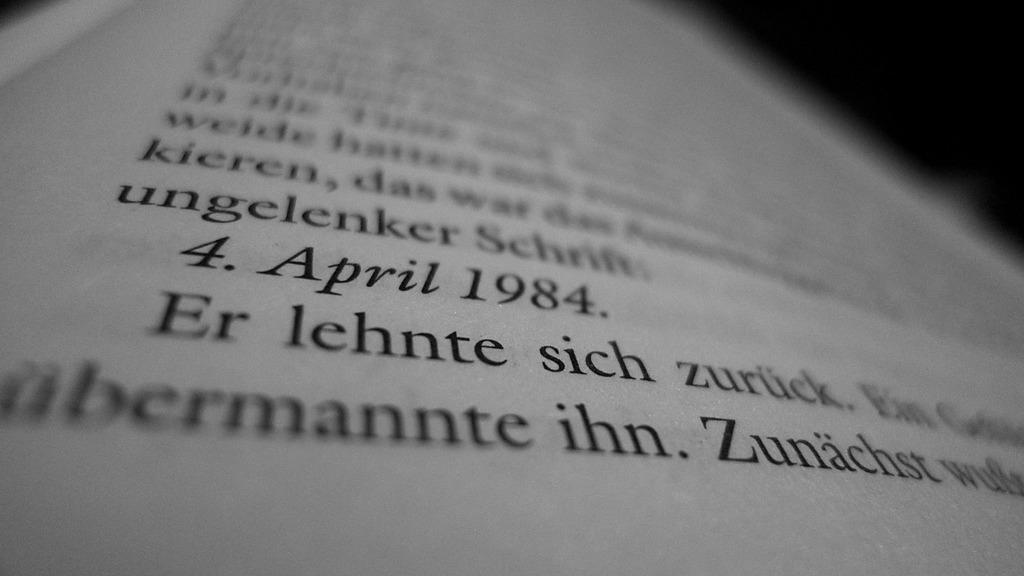What is the date given?
Ensure brevity in your answer.  4. april 1984. 